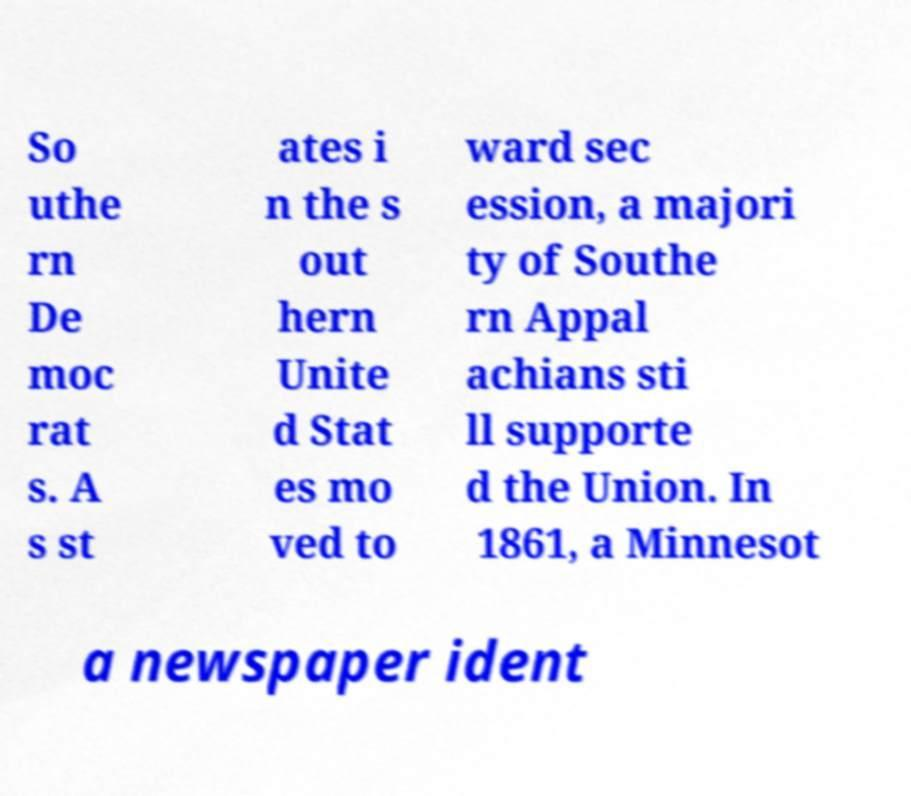I need the written content from this picture converted into text. Can you do that? So uthe rn De moc rat s. A s st ates i n the s out hern Unite d Stat es mo ved to ward sec ession, a majori ty of Southe rn Appal achians sti ll supporte d the Union. In 1861, a Minnesot a newspaper ident 